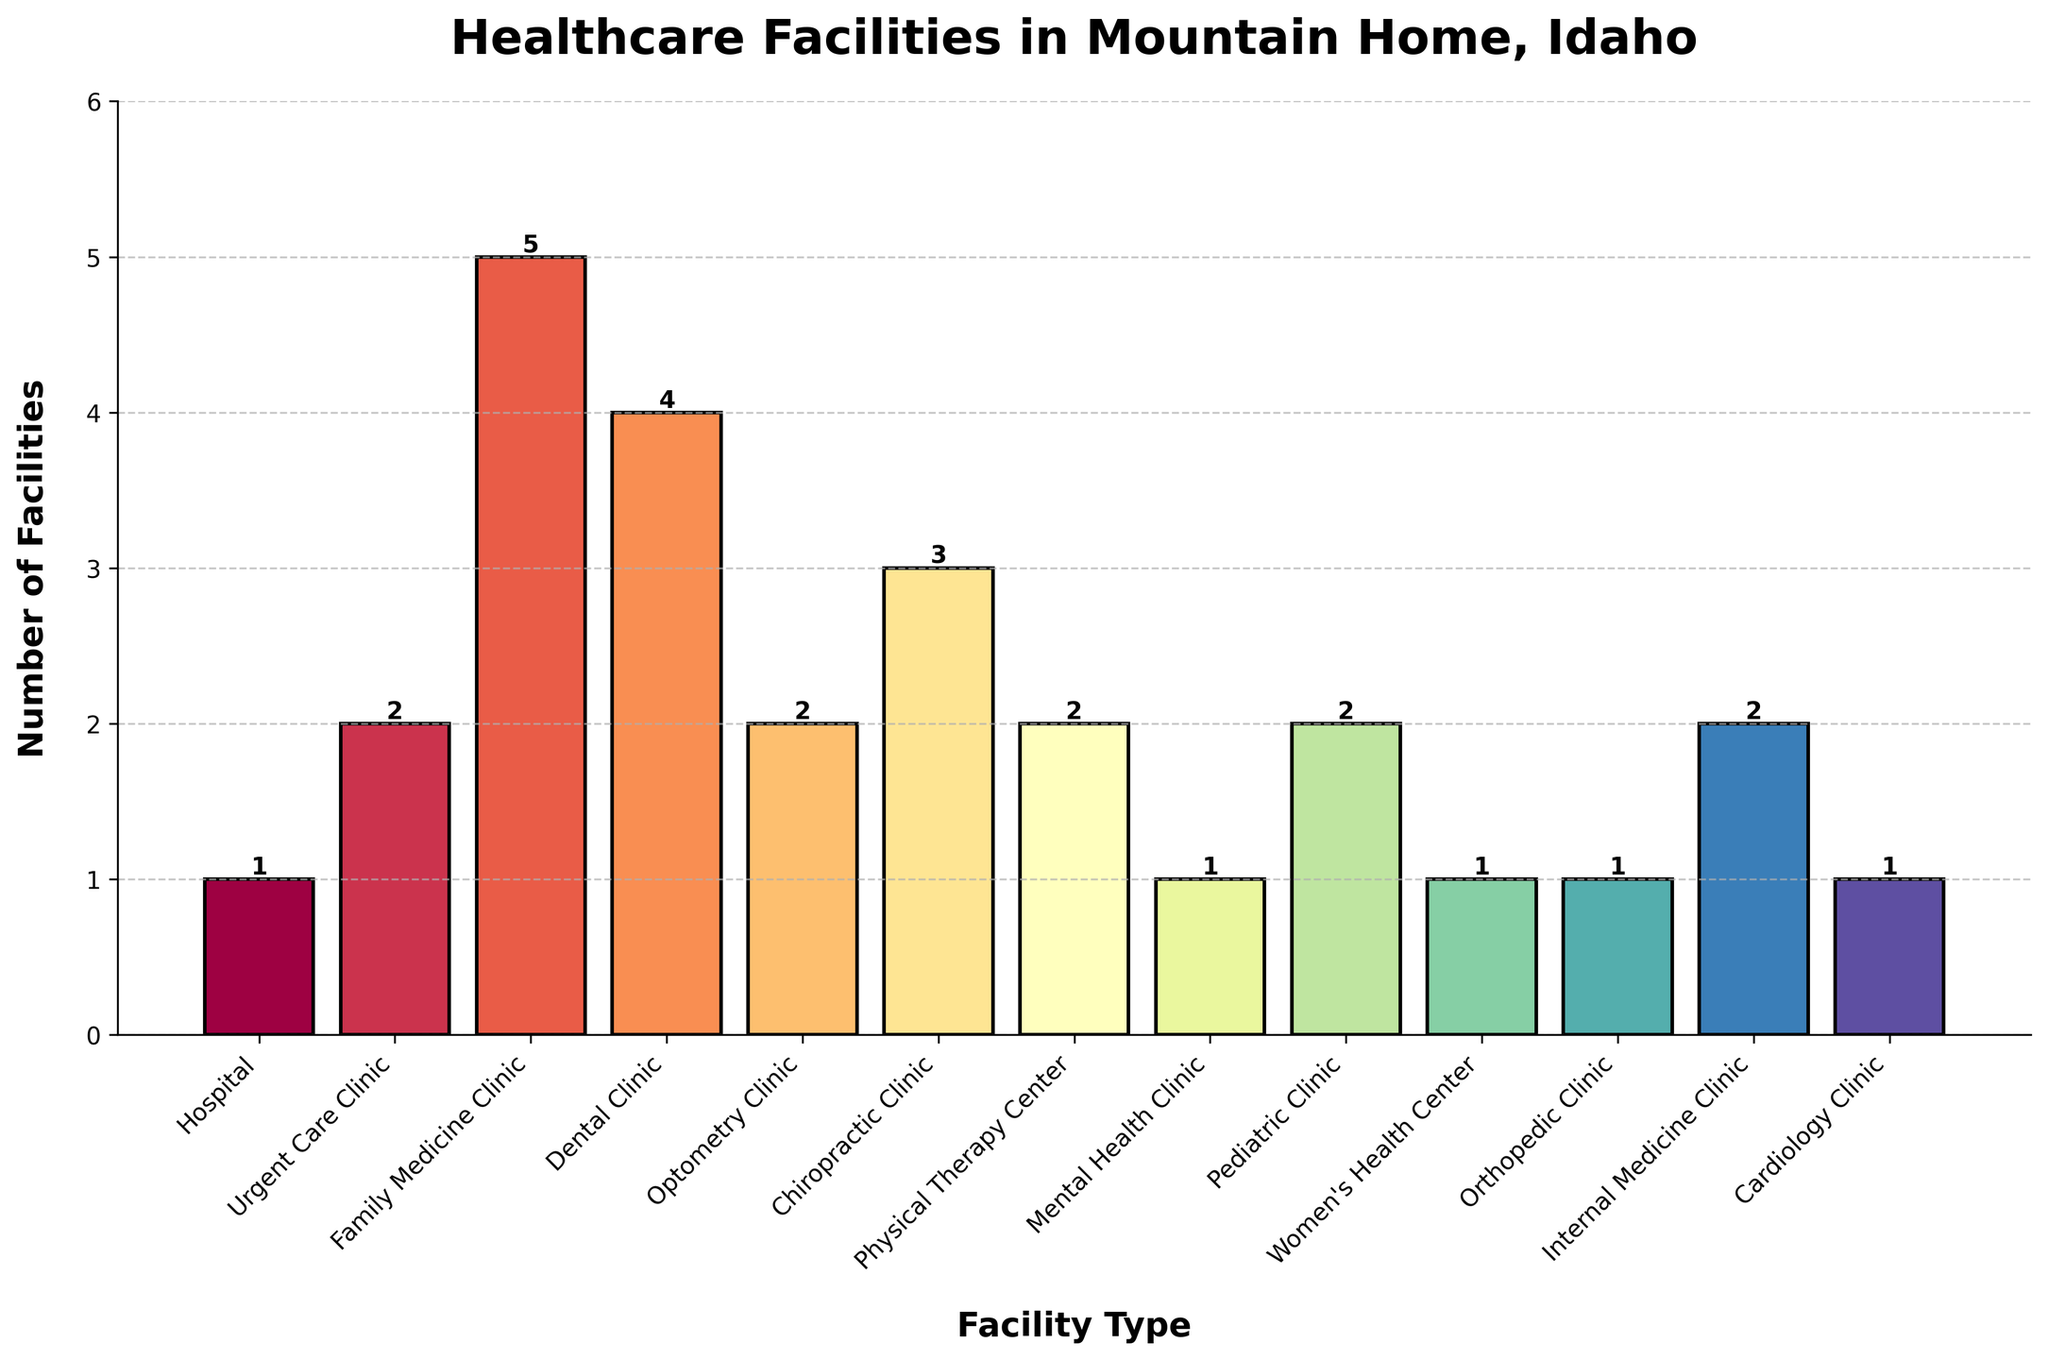Which type of healthcare facility has the highest number of facilities in Mountain Home? By looking at the heights of the bars, the Family Medicine Clinic has the tallest bar among all, indicating it has the highest count.
Answer: Family Medicine Clinic How many Family Medicine Clinics and Dental Clinics are there in total? The number of Family Medicine Clinics is 5, and the number of Dental Clinics is 4. Adding them together, we get 5 + 4 = 9.
Answer: 9 Are there more Mental Health Clinics or Women’s Health Centers in Mountain Home? By comparing the heights of the bars, both the Mental Health Clinic and the Women's Health Center have the same height, each representing 1 facility.
Answer: No, they are equal What is the difference in the number of facilities between Urgent Care Clinics and Chiropractic Clinics? The number of Urgent Care Clinics is 2, and the number of Chiropractic Clinics is 3. Subtracting, we get 3 - 2 = 1.
Answer: 1 Which facility type has exactly 2 clinics and is not Urgent Care Clinic? By looking at the bar heights that correspond to a count of 2, the facilities are Internal Medicine Clinic, Optometry Clinic, Pediatric Clinic, and Physical Therapy Center. We exclude the Urgent Care Clinic since it is specified in the question.
Answer: Internal Medicine Clinic, Optometry Clinic, Pediatric Clinic, and Physical Therapy Center Is the number of Optical Clinics and Pediatric Clinics combined less than the number of Family Medicine Clinics? The number of Optometry Clinics is 2, and the number of Pediatric Clinics is 2. Combined, they make 2 + 2 = 4. The Family Medicine Clinics number is 5. Since 4 < 5, the combined number is less.
Answer: Yes If you combine the number of Orthopedic Clinics and Cardiology Clinics, is it equal to the number of Urgent Care Clinics? Orthopedic Clinics have 1 facility, and Cardiology Clinics have 1 facility. Adding them together gives 1 + 1 = 2, which is equal to the number of Urgent Care Clinics (2).
Answer: Yes Which healthcare facility type has the smallest number of facilities in Mountain Home? By observing the chart, the smallest values are shared by several types, each with only 1 facility.
Answer: Multiple types (Hospital, Mental Health Clinic, Women's Health Center, Orthopedic Clinic, Cardiology Clinic) How does the number of Physical Therapy Centers compare to the number of Pediatric Clinics in Mountain Home? Both the Physical Therapy Center and Pediatric Clinic bars show a count of 2 facilities each, which means they are equal.
Answer: They are equal If you were to open one more Dental Clinic, how many facilities would there be in total for this type? The current number of Dental Clinics is 4. Adding one more would make 4 + 1 = 5.
Answer: 5 